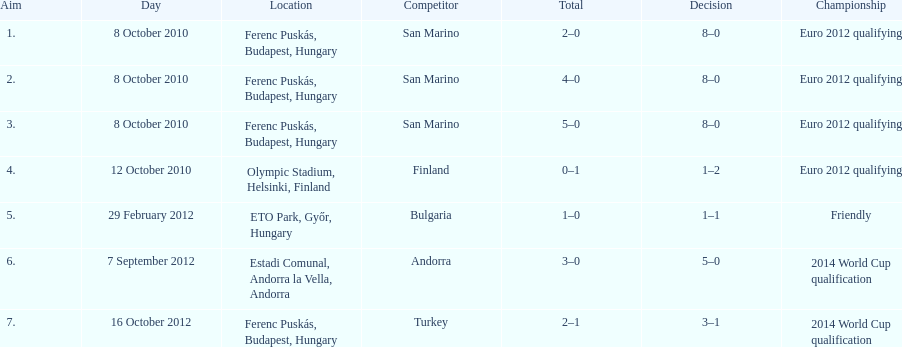In what year was szalai's first international goal? 2010. 